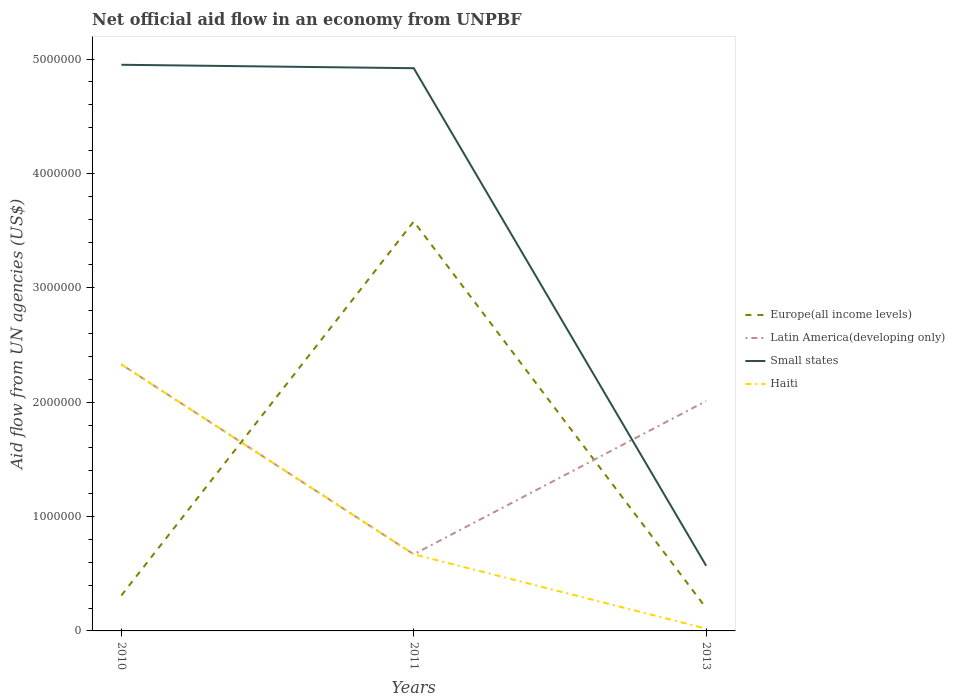How many different coloured lines are there?
Ensure brevity in your answer.  4. Is the number of lines equal to the number of legend labels?
Your answer should be compact. Yes. Across all years, what is the maximum net official aid flow in Europe(all income levels)?
Provide a short and direct response. 2.00e+05. What is the total net official aid flow in Haiti in the graph?
Offer a terse response. 6.50e+05. What is the difference between the highest and the second highest net official aid flow in Europe(all income levels)?
Offer a very short reply. 3.38e+06. Is the net official aid flow in Haiti strictly greater than the net official aid flow in Europe(all income levels) over the years?
Your answer should be compact. No. How many lines are there?
Ensure brevity in your answer.  4. What is the difference between two consecutive major ticks on the Y-axis?
Ensure brevity in your answer.  1.00e+06. Does the graph contain any zero values?
Your response must be concise. No. Does the graph contain grids?
Provide a short and direct response. No. How many legend labels are there?
Offer a terse response. 4. What is the title of the graph?
Your response must be concise. Net official aid flow in an economy from UNPBF. What is the label or title of the Y-axis?
Keep it short and to the point. Aid flow from UN agencies (US$). What is the Aid flow from UN agencies (US$) in Latin America(developing only) in 2010?
Give a very brief answer. 2.33e+06. What is the Aid flow from UN agencies (US$) of Small states in 2010?
Make the answer very short. 4.95e+06. What is the Aid flow from UN agencies (US$) of Haiti in 2010?
Ensure brevity in your answer.  2.33e+06. What is the Aid flow from UN agencies (US$) in Europe(all income levels) in 2011?
Provide a succinct answer. 3.58e+06. What is the Aid flow from UN agencies (US$) in Latin America(developing only) in 2011?
Offer a very short reply. 6.70e+05. What is the Aid flow from UN agencies (US$) of Small states in 2011?
Offer a terse response. 4.92e+06. What is the Aid flow from UN agencies (US$) of Haiti in 2011?
Keep it short and to the point. 6.70e+05. What is the Aid flow from UN agencies (US$) in Latin America(developing only) in 2013?
Make the answer very short. 2.01e+06. What is the Aid flow from UN agencies (US$) in Small states in 2013?
Your response must be concise. 5.70e+05. Across all years, what is the maximum Aid flow from UN agencies (US$) of Europe(all income levels)?
Give a very brief answer. 3.58e+06. Across all years, what is the maximum Aid flow from UN agencies (US$) in Latin America(developing only)?
Ensure brevity in your answer.  2.33e+06. Across all years, what is the maximum Aid flow from UN agencies (US$) in Small states?
Provide a succinct answer. 4.95e+06. Across all years, what is the maximum Aid flow from UN agencies (US$) of Haiti?
Make the answer very short. 2.33e+06. Across all years, what is the minimum Aid flow from UN agencies (US$) of Latin America(developing only)?
Your answer should be very brief. 6.70e+05. Across all years, what is the minimum Aid flow from UN agencies (US$) in Small states?
Your response must be concise. 5.70e+05. What is the total Aid flow from UN agencies (US$) in Europe(all income levels) in the graph?
Offer a terse response. 4.09e+06. What is the total Aid flow from UN agencies (US$) of Latin America(developing only) in the graph?
Your answer should be compact. 5.01e+06. What is the total Aid flow from UN agencies (US$) in Small states in the graph?
Your answer should be very brief. 1.04e+07. What is the total Aid flow from UN agencies (US$) in Haiti in the graph?
Your answer should be compact. 3.02e+06. What is the difference between the Aid flow from UN agencies (US$) in Europe(all income levels) in 2010 and that in 2011?
Your answer should be very brief. -3.27e+06. What is the difference between the Aid flow from UN agencies (US$) in Latin America(developing only) in 2010 and that in 2011?
Provide a short and direct response. 1.66e+06. What is the difference between the Aid flow from UN agencies (US$) in Small states in 2010 and that in 2011?
Keep it short and to the point. 3.00e+04. What is the difference between the Aid flow from UN agencies (US$) of Haiti in 2010 and that in 2011?
Provide a succinct answer. 1.66e+06. What is the difference between the Aid flow from UN agencies (US$) in Small states in 2010 and that in 2013?
Your response must be concise. 4.38e+06. What is the difference between the Aid flow from UN agencies (US$) in Haiti in 2010 and that in 2013?
Your response must be concise. 2.31e+06. What is the difference between the Aid flow from UN agencies (US$) of Europe(all income levels) in 2011 and that in 2013?
Offer a very short reply. 3.38e+06. What is the difference between the Aid flow from UN agencies (US$) in Latin America(developing only) in 2011 and that in 2013?
Ensure brevity in your answer.  -1.34e+06. What is the difference between the Aid flow from UN agencies (US$) of Small states in 2011 and that in 2013?
Offer a very short reply. 4.35e+06. What is the difference between the Aid flow from UN agencies (US$) of Haiti in 2011 and that in 2013?
Your answer should be very brief. 6.50e+05. What is the difference between the Aid flow from UN agencies (US$) of Europe(all income levels) in 2010 and the Aid flow from UN agencies (US$) of Latin America(developing only) in 2011?
Your response must be concise. -3.60e+05. What is the difference between the Aid flow from UN agencies (US$) in Europe(all income levels) in 2010 and the Aid flow from UN agencies (US$) in Small states in 2011?
Your response must be concise. -4.61e+06. What is the difference between the Aid flow from UN agencies (US$) in Europe(all income levels) in 2010 and the Aid flow from UN agencies (US$) in Haiti in 2011?
Offer a very short reply. -3.60e+05. What is the difference between the Aid flow from UN agencies (US$) of Latin America(developing only) in 2010 and the Aid flow from UN agencies (US$) of Small states in 2011?
Offer a very short reply. -2.59e+06. What is the difference between the Aid flow from UN agencies (US$) of Latin America(developing only) in 2010 and the Aid flow from UN agencies (US$) of Haiti in 2011?
Make the answer very short. 1.66e+06. What is the difference between the Aid flow from UN agencies (US$) in Small states in 2010 and the Aid flow from UN agencies (US$) in Haiti in 2011?
Provide a short and direct response. 4.28e+06. What is the difference between the Aid flow from UN agencies (US$) of Europe(all income levels) in 2010 and the Aid flow from UN agencies (US$) of Latin America(developing only) in 2013?
Give a very brief answer. -1.70e+06. What is the difference between the Aid flow from UN agencies (US$) of Europe(all income levels) in 2010 and the Aid flow from UN agencies (US$) of Haiti in 2013?
Give a very brief answer. 2.90e+05. What is the difference between the Aid flow from UN agencies (US$) in Latin America(developing only) in 2010 and the Aid flow from UN agencies (US$) in Small states in 2013?
Your response must be concise. 1.76e+06. What is the difference between the Aid flow from UN agencies (US$) in Latin America(developing only) in 2010 and the Aid flow from UN agencies (US$) in Haiti in 2013?
Ensure brevity in your answer.  2.31e+06. What is the difference between the Aid flow from UN agencies (US$) of Small states in 2010 and the Aid flow from UN agencies (US$) of Haiti in 2013?
Provide a short and direct response. 4.93e+06. What is the difference between the Aid flow from UN agencies (US$) in Europe(all income levels) in 2011 and the Aid flow from UN agencies (US$) in Latin America(developing only) in 2013?
Provide a short and direct response. 1.57e+06. What is the difference between the Aid flow from UN agencies (US$) of Europe(all income levels) in 2011 and the Aid flow from UN agencies (US$) of Small states in 2013?
Provide a succinct answer. 3.01e+06. What is the difference between the Aid flow from UN agencies (US$) of Europe(all income levels) in 2011 and the Aid flow from UN agencies (US$) of Haiti in 2013?
Make the answer very short. 3.56e+06. What is the difference between the Aid flow from UN agencies (US$) in Latin America(developing only) in 2011 and the Aid flow from UN agencies (US$) in Haiti in 2013?
Offer a very short reply. 6.50e+05. What is the difference between the Aid flow from UN agencies (US$) of Small states in 2011 and the Aid flow from UN agencies (US$) of Haiti in 2013?
Make the answer very short. 4.90e+06. What is the average Aid flow from UN agencies (US$) in Europe(all income levels) per year?
Offer a terse response. 1.36e+06. What is the average Aid flow from UN agencies (US$) of Latin America(developing only) per year?
Offer a very short reply. 1.67e+06. What is the average Aid flow from UN agencies (US$) in Small states per year?
Your answer should be compact. 3.48e+06. What is the average Aid flow from UN agencies (US$) in Haiti per year?
Give a very brief answer. 1.01e+06. In the year 2010, what is the difference between the Aid flow from UN agencies (US$) of Europe(all income levels) and Aid flow from UN agencies (US$) of Latin America(developing only)?
Ensure brevity in your answer.  -2.02e+06. In the year 2010, what is the difference between the Aid flow from UN agencies (US$) in Europe(all income levels) and Aid flow from UN agencies (US$) in Small states?
Ensure brevity in your answer.  -4.64e+06. In the year 2010, what is the difference between the Aid flow from UN agencies (US$) of Europe(all income levels) and Aid flow from UN agencies (US$) of Haiti?
Ensure brevity in your answer.  -2.02e+06. In the year 2010, what is the difference between the Aid flow from UN agencies (US$) of Latin America(developing only) and Aid flow from UN agencies (US$) of Small states?
Provide a short and direct response. -2.62e+06. In the year 2010, what is the difference between the Aid flow from UN agencies (US$) of Latin America(developing only) and Aid flow from UN agencies (US$) of Haiti?
Provide a succinct answer. 0. In the year 2010, what is the difference between the Aid flow from UN agencies (US$) in Small states and Aid flow from UN agencies (US$) in Haiti?
Make the answer very short. 2.62e+06. In the year 2011, what is the difference between the Aid flow from UN agencies (US$) of Europe(all income levels) and Aid flow from UN agencies (US$) of Latin America(developing only)?
Your answer should be compact. 2.91e+06. In the year 2011, what is the difference between the Aid flow from UN agencies (US$) in Europe(all income levels) and Aid flow from UN agencies (US$) in Small states?
Offer a very short reply. -1.34e+06. In the year 2011, what is the difference between the Aid flow from UN agencies (US$) in Europe(all income levels) and Aid flow from UN agencies (US$) in Haiti?
Keep it short and to the point. 2.91e+06. In the year 2011, what is the difference between the Aid flow from UN agencies (US$) in Latin America(developing only) and Aid flow from UN agencies (US$) in Small states?
Keep it short and to the point. -4.25e+06. In the year 2011, what is the difference between the Aid flow from UN agencies (US$) of Latin America(developing only) and Aid flow from UN agencies (US$) of Haiti?
Ensure brevity in your answer.  0. In the year 2011, what is the difference between the Aid flow from UN agencies (US$) in Small states and Aid flow from UN agencies (US$) in Haiti?
Ensure brevity in your answer.  4.25e+06. In the year 2013, what is the difference between the Aid flow from UN agencies (US$) of Europe(all income levels) and Aid flow from UN agencies (US$) of Latin America(developing only)?
Ensure brevity in your answer.  -1.81e+06. In the year 2013, what is the difference between the Aid flow from UN agencies (US$) of Europe(all income levels) and Aid flow from UN agencies (US$) of Small states?
Provide a short and direct response. -3.70e+05. In the year 2013, what is the difference between the Aid flow from UN agencies (US$) of Europe(all income levels) and Aid flow from UN agencies (US$) of Haiti?
Provide a succinct answer. 1.80e+05. In the year 2013, what is the difference between the Aid flow from UN agencies (US$) in Latin America(developing only) and Aid flow from UN agencies (US$) in Small states?
Your response must be concise. 1.44e+06. In the year 2013, what is the difference between the Aid flow from UN agencies (US$) in Latin America(developing only) and Aid flow from UN agencies (US$) in Haiti?
Make the answer very short. 1.99e+06. What is the ratio of the Aid flow from UN agencies (US$) in Europe(all income levels) in 2010 to that in 2011?
Provide a succinct answer. 0.09. What is the ratio of the Aid flow from UN agencies (US$) of Latin America(developing only) in 2010 to that in 2011?
Keep it short and to the point. 3.48. What is the ratio of the Aid flow from UN agencies (US$) of Haiti in 2010 to that in 2011?
Ensure brevity in your answer.  3.48. What is the ratio of the Aid flow from UN agencies (US$) in Europe(all income levels) in 2010 to that in 2013?
Your response must be concise. 1.55. What is the ratio of the Aid flow from UN agencies (US$) of Latin America(developing only) in 2010 to that in 2013?
Provide a short and direct response. 1.16. What is the ratio of the Aid flow from UN agencies (US$) in Small states in 2010 to that in 2013?
Provide a short and direct response. 8.68. What is the ratio of the Aid flow from UN agencies (US$) of Haiti in 2010 to that in 2013?
Offer a terse response. 116.5. What is the ratio of the Aid flow from UN agencies (US$) of Latin America(developing only) in 2011 to that in 2013?
Your response must be concise. 0.33. What is the ratio of the Aid flow from UN agencies (US$) of Small states in 2011 to that in 2013?
Your answer should be compact. 8.63. What is the ratio of the Aid flow from UN agencies (US$) of Haiti in 2011 to that in 2013?
Your answer should be compact. 33.5. What is the difference between the highest and the second highest Aid flow from UN agencies (US$) in Europe(all income levels)?
Provide a succinct answer. 3.27e+06. What is the difference between the highest and the second highest Aid flow from UN agencies (US$) of Small states?
Offer a very short reply. 3.00e+04. What is the difference between the highest and the second highest Aid flow from UN agencies (US$) of Haiti?
Offer a terse response. 1.66e+06. What is the difference between the highest and the lowest Aid flow from UN agencies (US$) in Europe(all income levels)?
Your answer should be very brief. 3.38e+06. What is the difference between the highest and the lowest Aid flow from UN agencies (US$) of Latin America(developing only)?
Your response must be concise. 1.66e+06. What is the difference between the highest and the lowest Aid flow from UN agencies (US$) of Small states?
Provide a succinct answer. 4.38e+06. What is the difference between the highest and the lowest Aid flow from UN agencies (US$) of Haiti?
Keep it short and to the point. 2.31e+06. 